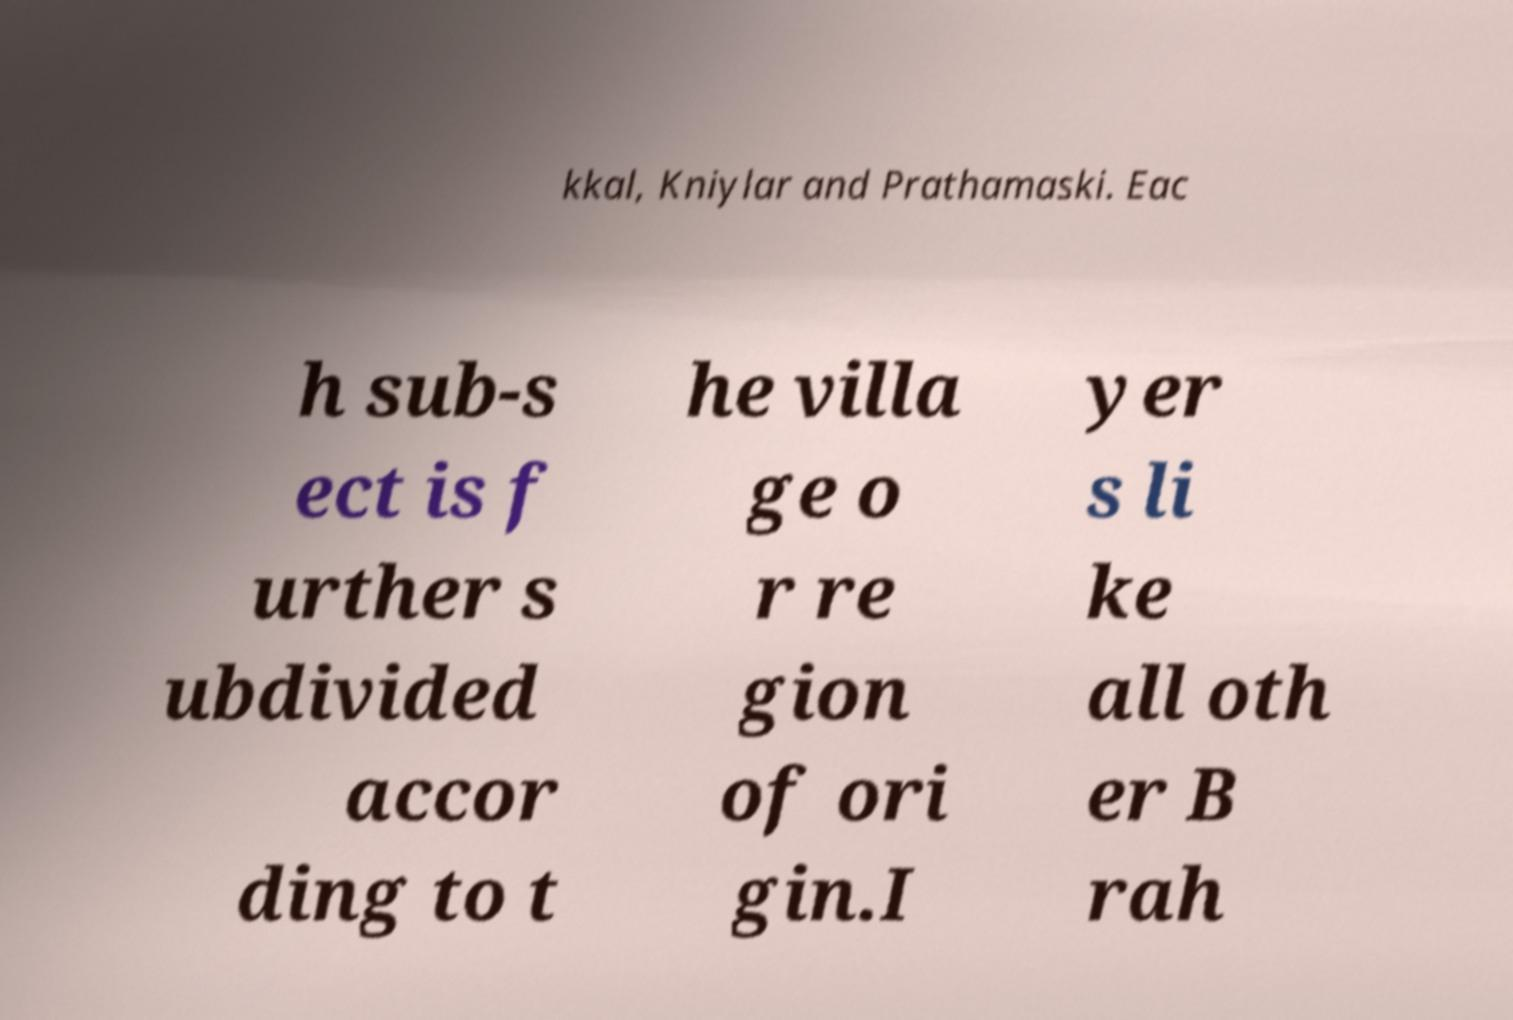I need the written content from this picture converted into text. Can you do that? kkal, Kniylar and Prathamaski. Eac h sub-s ect is f urther s ubdivided accor ding to t he villa ge o r re gion of ori gin.I yer s li ke all oth er B rah 